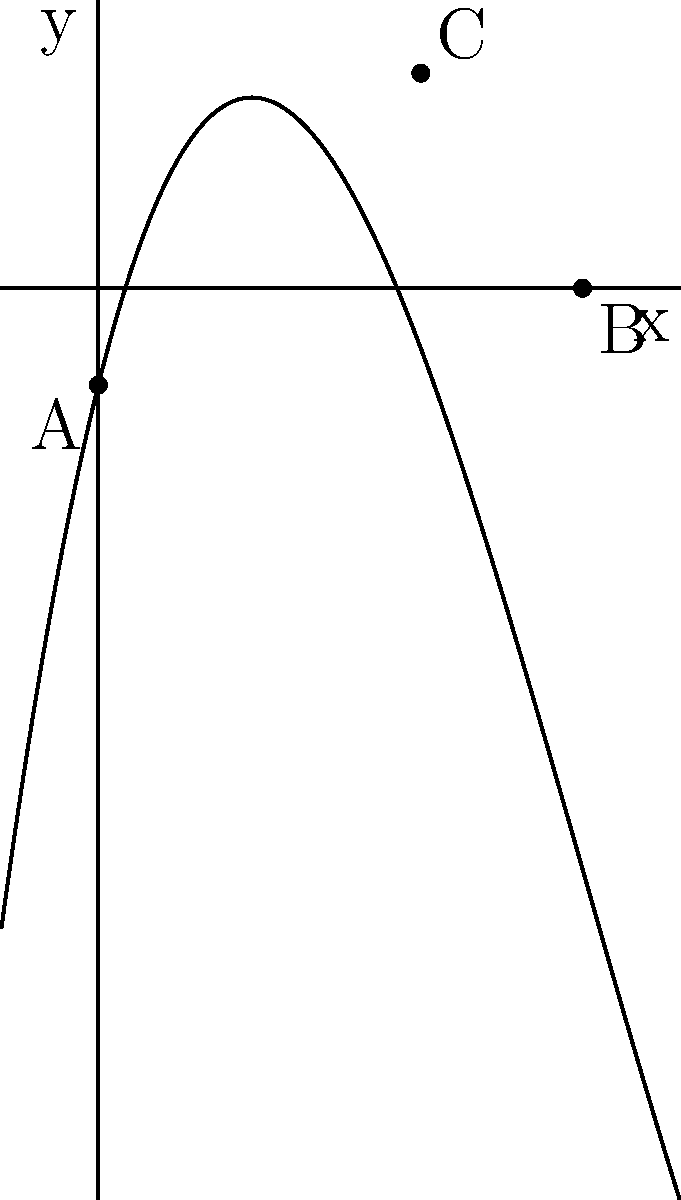Consider the polynomial function $f(x) = 0.1x^3 - 1.5x^2 + 4x - 1$, which represents the path of a spiritual journey. The x-axis represents time, and the y-axis represents spiritual enlightenment. Points A, B, and C are significant moments in this journey. What do the roots of this polynomial signify, and how many roots are there in total? To answer this question, let's analyze the polynomial function step-by-step:

1. The roots of a polynomial function are the x-intercepts, where $f(x) = 0$.

2. From the graph, we can see two x-intercepts:
   - Point A at (0, -1)
   - Point B at (5, 0)

3. Point A is not actually a root because $f(0) = -1 \neq 0$.

4. Point B is a root because $f(5) = 0$.

5. The polynomial is of degree 3 (cubic), so it can have at most 3 real roots.

6. The graph shows that there is another root between x = 0 and x = 1, which is not labeled.

7. In the context of a spiritual journey:
   - The unlabeled root near x = 0 could represent the beginning of the journey.
   - Point B (x = 5) could represent a moment of spiritual equilibrium or transformation.
   - Point C, while not a root, represents the peak of spiritual enlightenment in this journey.

8. The roots signify moments when the spiritual seeker's enlightenment level crosses the baseline (y = 0), potentially indicating significant transitions or revelations in their journey.

Therefore, there are 2 roots visible in the given domain, representing key moments in the spiritual journey where the seeker's enlightenment level aligns with their initial state.
Answer: 2 roots, representing spiritual equilibrium points 